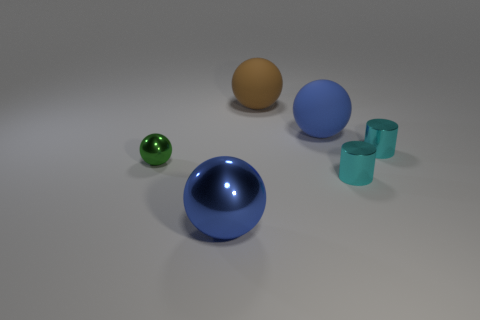Subtract all big spheres. How many spheres are left? 1 Subtract 2 balls. How many balls are left? 2 Add 1 cylinders. How many objects exist? 7 Subtract all purple spheres. Subtract all yellow cylinders. How many spheres are left? 4 Subtract all spheres. How many objects are left? 2 Add 3 big green cylinders. How many big green cylinders exist? 3 Subtract 0 purple cubes. How many objects are left? 6 Subtract all tiny shiny objects. Subtract all metallic cylinders. How many objects are left? 1 Add 6 blue shiny balls. How many blue shiny balls are left? 7 